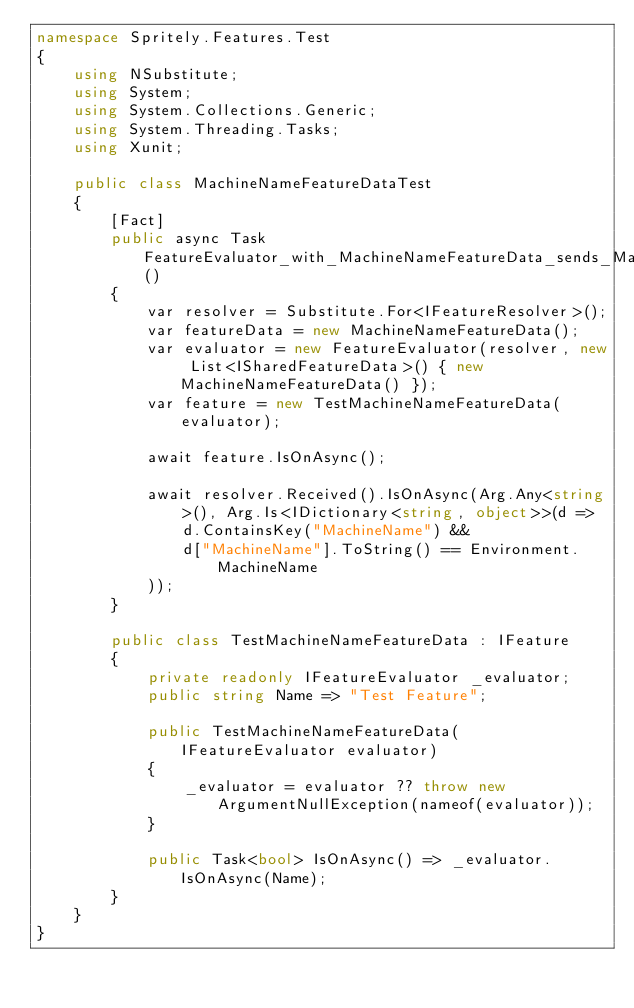<code> <loc_0><loc_0><loc_500><loc_500><_C#_>namespace Spritely.Features.Test
{
    using NSubstitute;
    using System;
    using System.Collections.Generic;
    using System.Threading.Tasks;
    using Xunit;

    public class MachineNameFeatureDataTest
    {
        [Fact]
        public async Task FeatureEvaluator_with_MachineNameFeatureData_sends_MachineName_to_resolver()
        {
            var resolver = Substitute.For<IFeatureResolver>();
            var featureData = new MachineNameFeatureData();
            var evaluator = new FeatureEvaluator(resolver, new List<ISharedFeatureData>() { new MachineNameFeatureData() });
            var feature = new TestMachineNameFeatureData(evaluator);

            await feature.IsOnAsync();

            await resolver.Received().IsOnAsync(Arg.Any<string>(), Arg.Is<IDictionary<string, object>>(d =>
                d.ContainsKey("MachineName") &&
                d["MachineName"].ToString() == Environment.MachineName
            ));
        }

        public class TestMachineNameFeatureData : IFeature
        {
            private readonly IFeatureEvaluator _evaluator;
            public string Name => "Test Feature";

            public TestMachineNameFeatureData(IFeatureEvaluator evaluator)
            {
                _evaluator = evaluator ?? throw new ArgumentNullException(nameof(evaluator));
            }

            public Task<bool> IsOnAsync() => _evaluator.IsOnAsync(Name);
        }
    }
}
</code> 